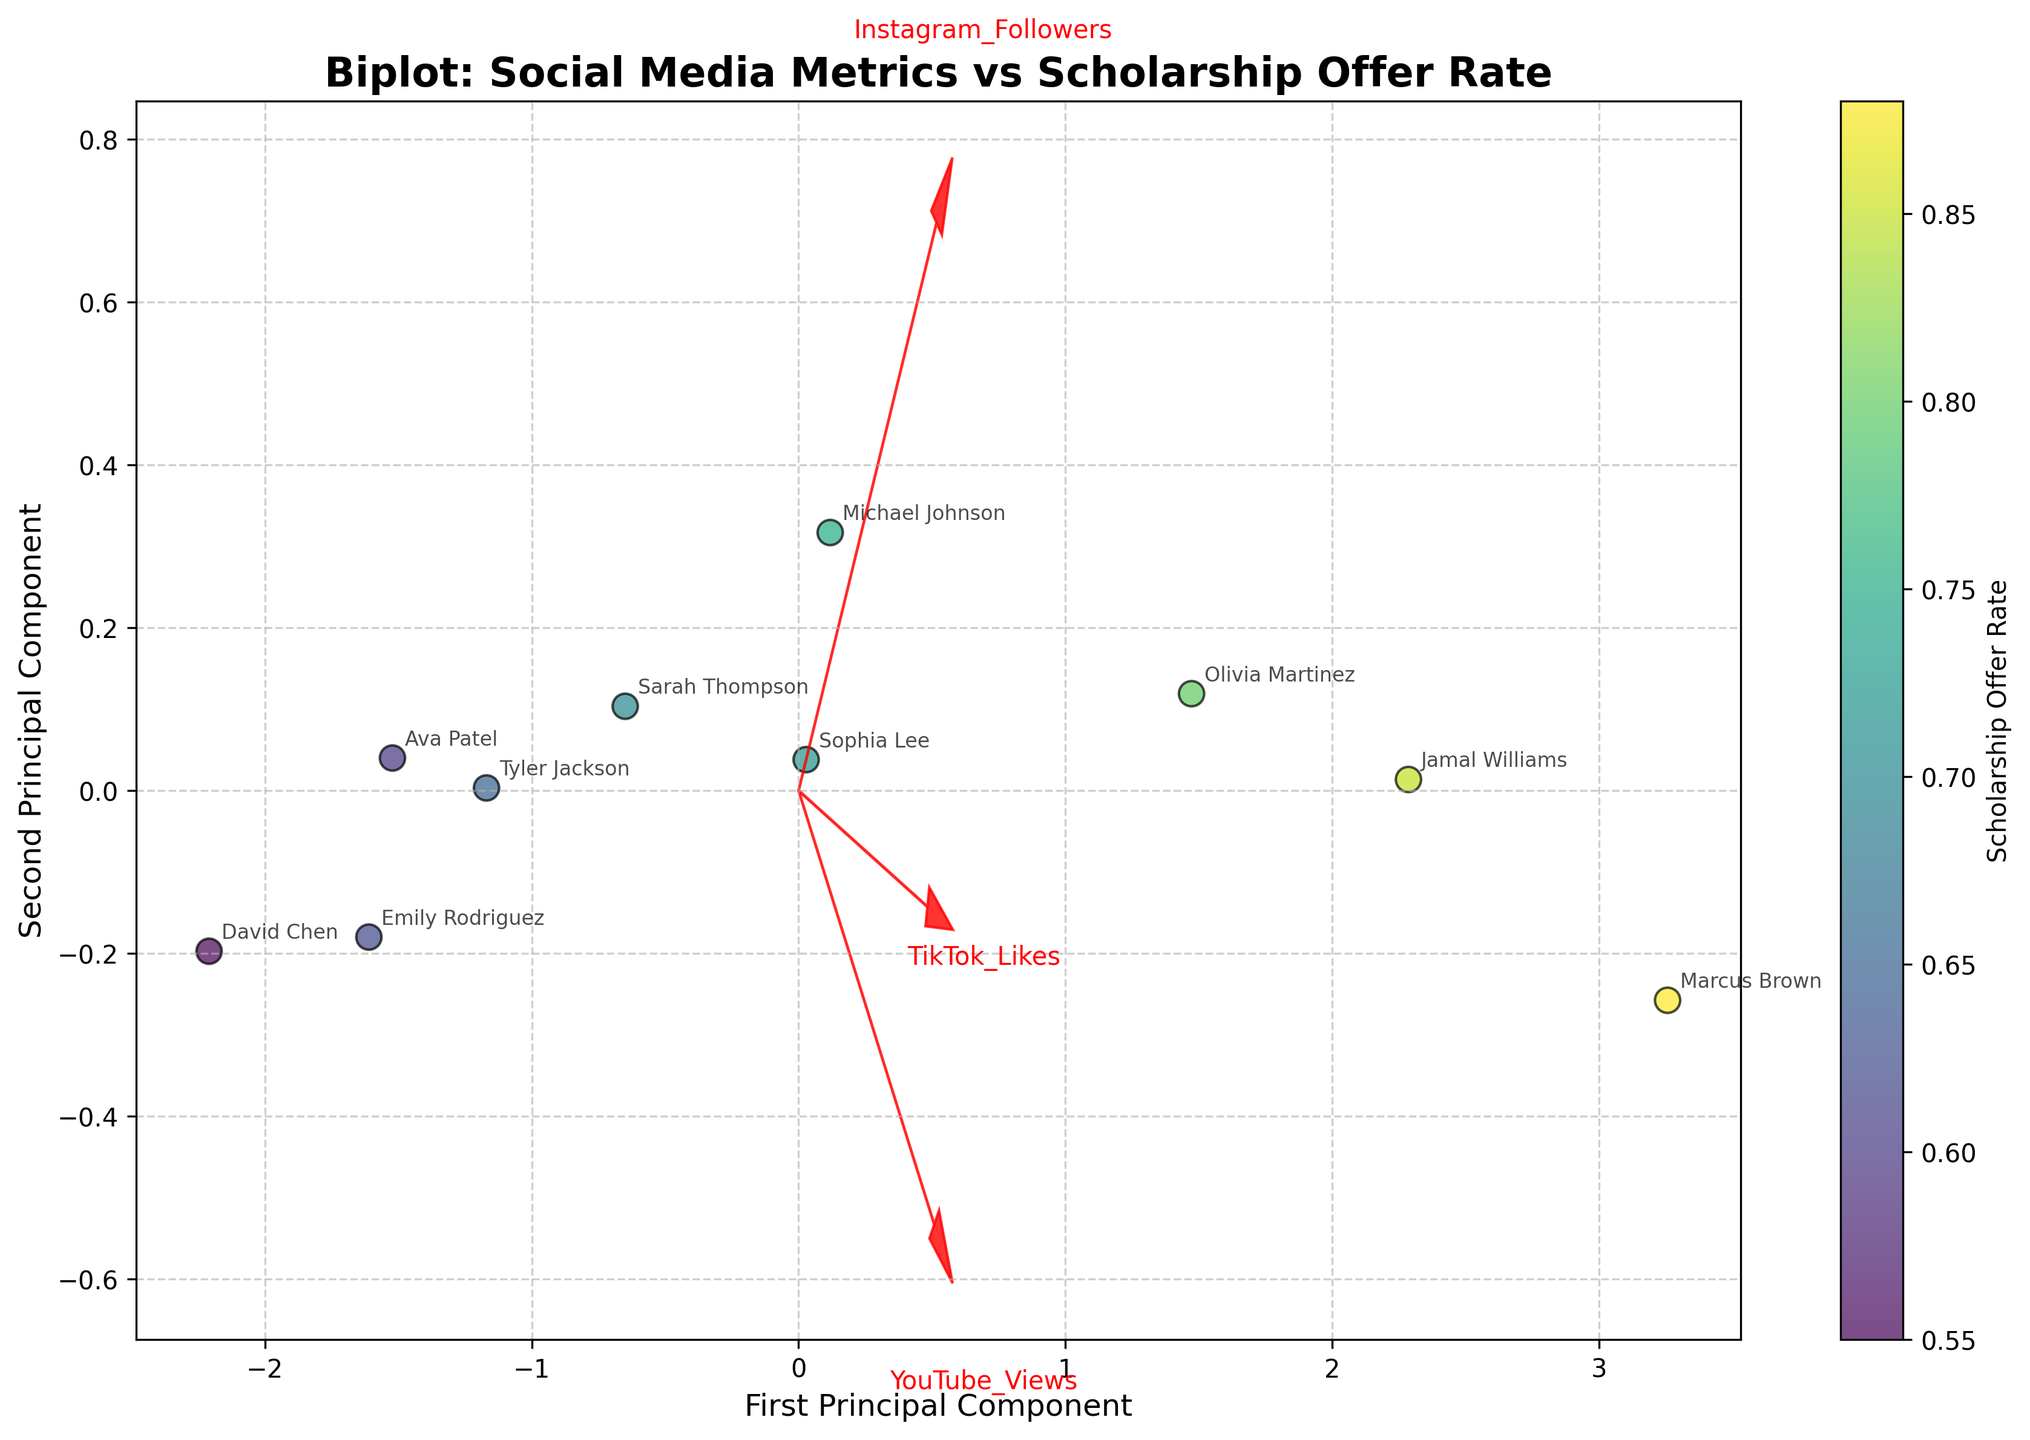What is the title of the figure? The title of the figure can be found at the top and it summarizes the content of the plot. It is the largest text element and provides context for the plot's data.
Answer: Biplot: Social Media Metrics vs Scholarship Offer Rate How many principal components are shown in the plot? The plot features two principal components, which are the axes labeled "First Principal Component" and "Second Principal Component".
Answer: Two What metric are the color codes in the scatter plot representing? The color bar on the right side of the plot signifies the metric, which in this case is indicated by the label on the color bar. This label is "Scholarship Offer Rate".
Answer: Scholarship Offer Rate Which athlete has the highest Scholarship Offer Rate? By examining the colors and referring to the color bar, Marcus Brown has the darkest hue which represents the highest scholarship offer rate.
Answer: Marcus Brown Which social media metric contributes most to the first principal component? The feature vector that extends furthest along the first principal component axis (horizontal) contributes most. It appears that "YouTube Views" has the longest vector.
Answer: YouTube Views Between "TikTok Likes" and "Instagram Followers," which metric has a stronger association with the second principal component? By observing the length and angle of the arrows pointing towards the second principal component (vertical), "TikTok Likes" seems to have a longer and more aligned vector, indicating a stronger association.
Answer: TikTok Likes How are the data points distributed in the plot? The data points are scattered across the plot, with no cluster being too tight. This might indicate a diversity in the social media metrics and scholarship offer rates among athletes.
Answer: Scattered Which athlete profiles are closest to the origin point (0,0) of the principal components? By noting the annotated names closest to the center of the plot where both principal component values are near zero, Emily Rodriguez and Tyler Jackson are quite central.
Answer: Emily Rodriguez, Tyler Jackson Are athletes with higher scholarship offer rates clustered together, or are they spread out across the plot? Looking at the colors indicating scholarship offer rates, athletes with higher rates (darker colors) are somewhat dispersed rather than forming a tight cluster in the figure.
Answer: Spread out 